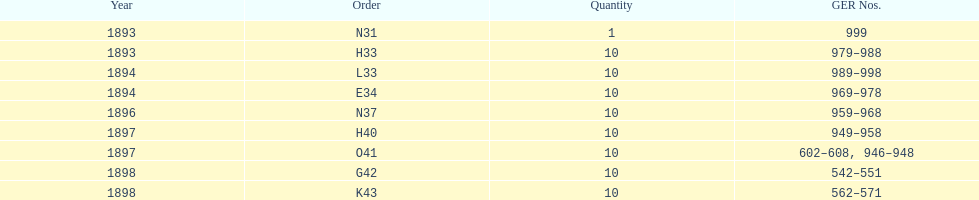Which order was the next order after l33? E34. 